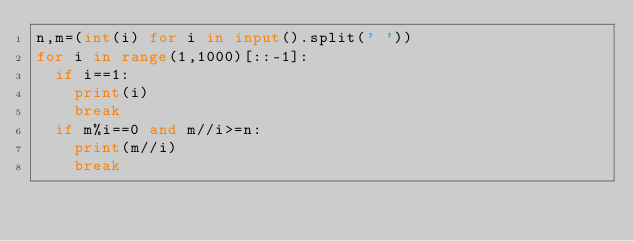<code> <loc_0><loc_0><loc_500><loc_500><_Python_>n,m=(int(i) for i in input().split(' '))
for i in range(1,1000)[::-1]:
  if i==1:
    print(i)
    break
  if m%i==0 and m//i>=n:
    print(m//i)
    break
</code> 